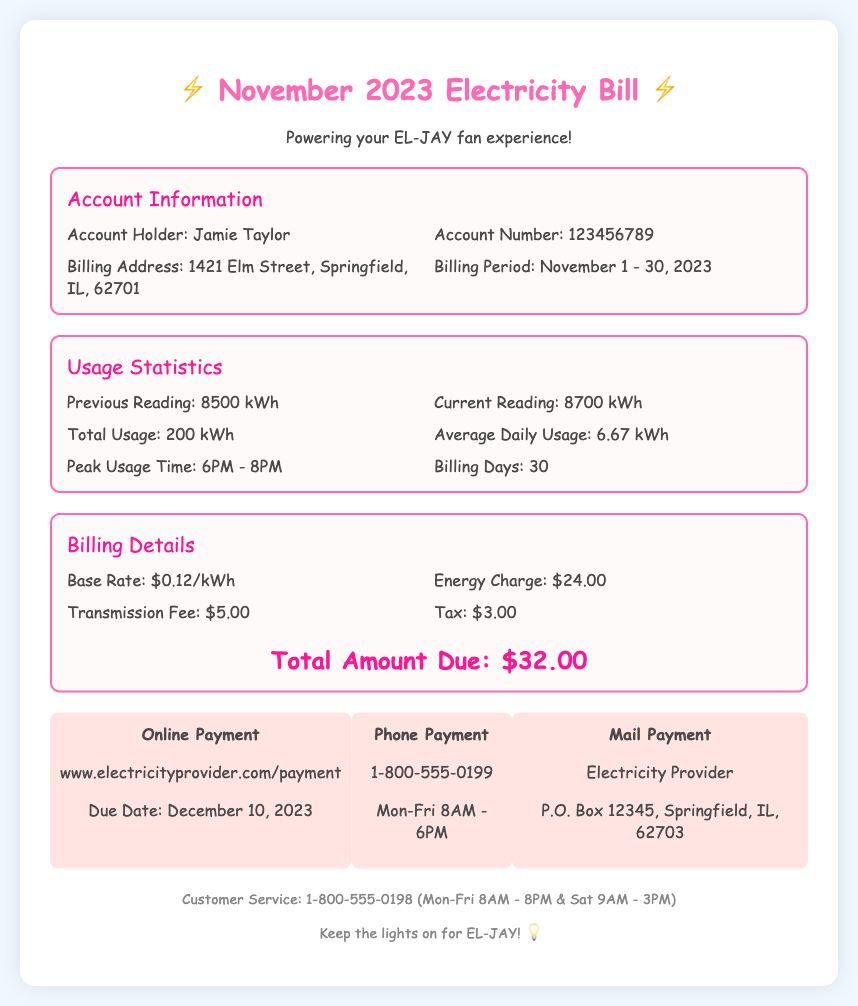What is the account holder's name? The account holder's name is listed at the top of the account information section in the document.
Answer: Jamie Taylor What is the total energy usage for November 2023? The total energy usage is calculated by finding the difference between the current reading and the previous reading in the usage statistics.
Answer: 200 kWh When is the billing period? The billing period is stated in the account information section and refers to the duration for which usage is measured.
Answer: November 1 - 30, 2023 What is the total amount due? The total amount due is specifically mentioned in the billing details section, summarizing the charges incurred.
Answer: $32.00 What is the peak usage time? The peak usage time is listed in the usage statistics section of the document, indicating when the highest energy consumption occurred.
Answer: 6PM - 8PM What is the base rate per kWh? The base rate can be found in the billing details and indicates the cost of the energy consumed in kilowatt-hours.
Answer: $0.12/kWh What is the due date for the payment? The due date is provided in the payment options section, specifying when the payment must be made.
Answer: December 10, 2023 How can I pay my bill online? Information about online payments is included in the payment options section, detailing how to pay through a specific website.
Answer: www.electricityprovider.com/payment What is the transmission fee? The transmission fee is specified in the billing details section as part of the overall charges.
Answer: $5.00 